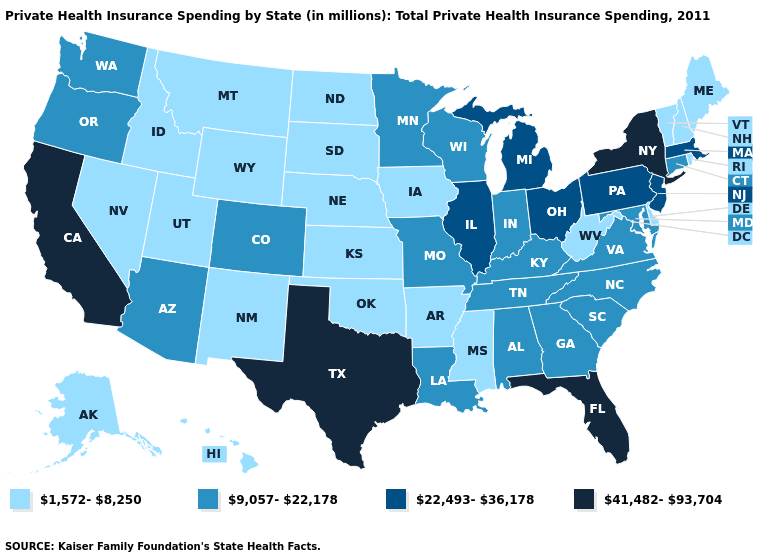Among the states that border South Carolina , which have the highest value?
Write a very short answer. Georgia, North Carolina. Name the states that have a value in the range 22,493-36,178?
Give a very brief answer. Illinois, Massachusetts, Michigan, New Jersey, Ohio, Pennsylvania. Name the states that have a value in the range 22,493-36,178?
Keep it brief. Illinois, Massachusetts, Michigan, New Jersey, Ohio, Pennsylvania. Which states have the lowest value in the South?
Write a very short answer. Arkansas, Delaware, Mississippi, Oklahoma, West Virginia. Among the states that border Maine , which have the lowest value?
Quick response, please. New Hampshire. Does Florida have the highest value in the South?
Write a very short answer. Yes. What is the value of Arizona?
Concise answer only. 9,057-22,178. What is the lowest value in the MidWest?
Give a very brief answer. 1,572-8,250. Name the states that have a value in the range 41,482-93,704?
Quick response, please. California, Florida, New York, Texas. Does Illinois have the highest value in the MidWest?
Keep it brief. Yes. Does the first symbol in the legend represent the smallest category?
Be succinct. Yes. What is the value of Pennsylvania?
Short answer required. 22,493-36,178. What is the value of Nevada?
Concise answer only. 1,572-8,250. Among the states that border New Mexico , does Arizona have the lowest value?
Concise answer only. No. What is the value of Tennessee?
Be succinct. 9,057-22,178. 